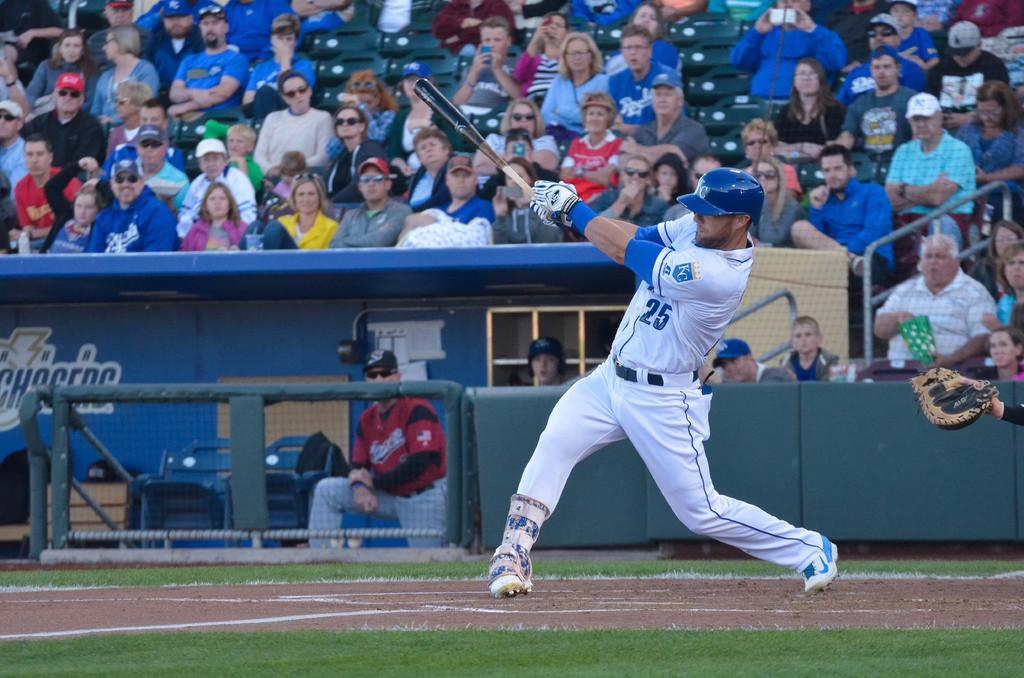<image>
Summarize the visual content of the image. a baseball player wearing number 25 jersey is batting 